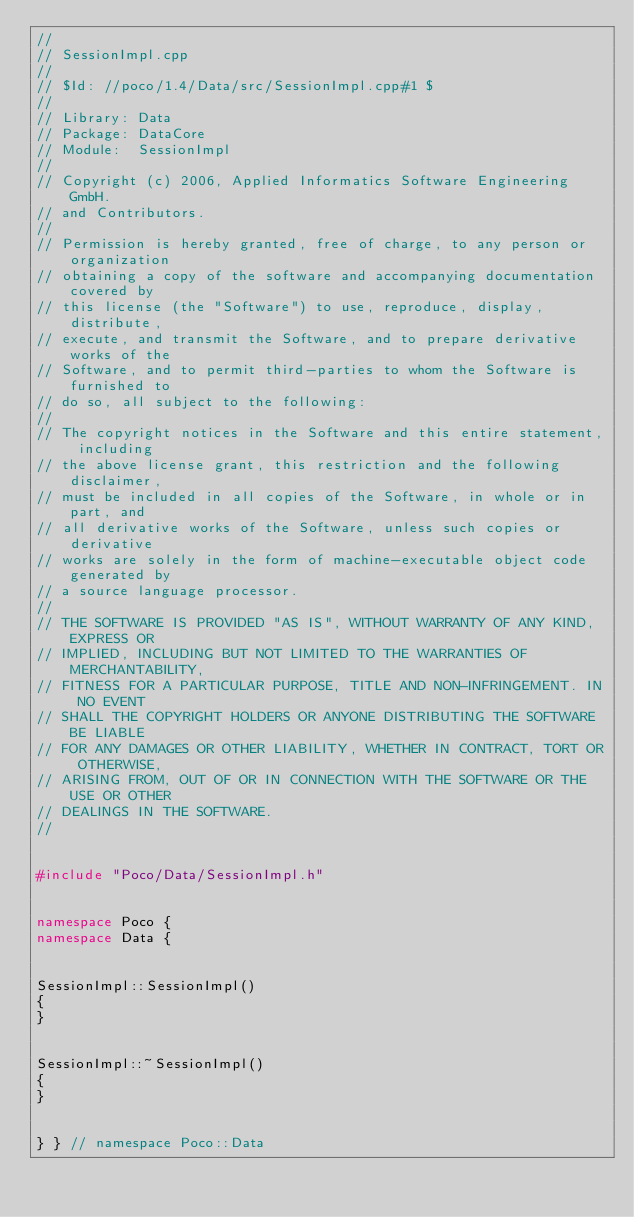Convert code to text. <code><loc_0><loc_0><loc_500><loc_500><_C++_>//
// SessionImpl.cpp
//
// $Id: //poco/1.4/Data/src/SessionImpl.cpp#1 $
//
// Library: Data
// Package: DataCore
// Module:  SessionImpl
//
// Copyright (c) 2006, Applied Informatics Software Engineering GmbH.
// and Contributors.
//
// Permission is hereby granted, free of charge, to any person or organization
// obtaining a copy of the software and accompanying documentation covered by
// this license (the "Software") to use, reproduce, display, distribute,
// execute, and transmit the Software, and to prepare derivative works of the
// Software, and to permit third-parties to whom the Software is furnished to
// do so, all subject to the following:
// 
// The copyright notices in the Software and this entire statement, including
// the above license grant, this restriction and the following disclaimer,
// must be included in all copies of the Software, in whole or in part, and
// all derivative works of the Software, unless such copies or derivative
// works are solely in the form of machine-executable object code generated by
// a source language processor.
// 
// THE SOFTWARE IS PROVIDED "AS IS", WITHOUT WARRANTY OF ANY KIND, EXPRESS OR
// IMPLIED, INCLUDING BUT NOT LIMITED TO THE WARRANTIES OF MERCHANTABILITY,
// FITNESS FOR A PARTICULAR PURPOSE, TITLE AND NON-INFRINGEMENT. IN NO EVENT
// SHALL THE COPYRIGHT HOLDERS OR ANYONE DISTRIBUTING THE SOFTWARE BE LIABLE
// FOR ANY DAMAGES OR OTHER LIABILITY, WHETHER IN CONTRACT, TORT OR OTHERWISE,
// ARISING FROM, OUT OF OR IN CONNECTION WITH THE SOFTWARE OR THE USE OR OTHER
// DEALINGS IN THE SOFTWARE.
//


#include "Poco/Data/SessionImpl.h"


namespace Poco {
namespace Data {


SessionImpl::SessionImpl()
{
}


SessionImpl::~SessionImpl()
{
}


} } // namespace Poco::Data
</code> 